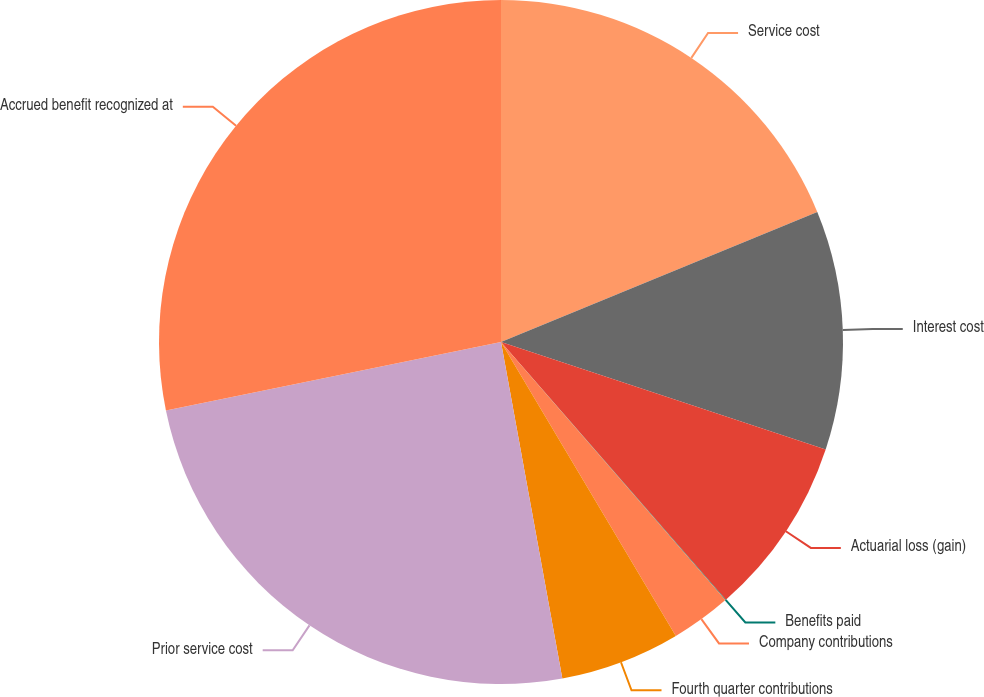Convert chart. <chart><loc_0><loc_0><loc_500><loc_500><pie_chart><fcel>Service cost<fcel>Interest cost<fcel>Actuarial loss (gain)<fcel>Benefits paid<fcel>Company contributions<fcel>Fourth quarter contributions<fcel>Prior service cost<fcel>Accrued benefit recognized at<nl><fcel>18.79%<fcel>11.3%<fcel>8.49%<fcel>0.03%<fcel>2.85%<fcel>5.67%<fcel>24.66%<fcel>28.21%<nl></chart> 